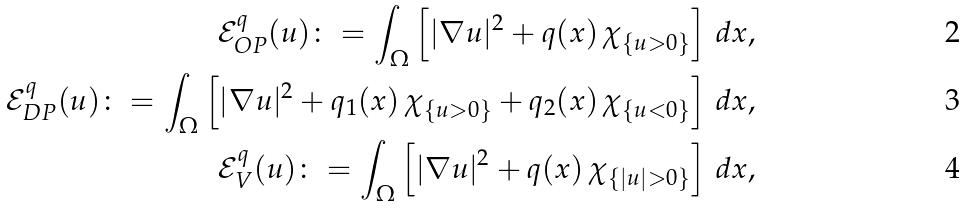Convert formula to latex. <formula><loc_0><loc_0><loc_500><loc_500>\mathcal { E } ^ { q } _ { O P } ( u ) \colon = \int _ { \Omega } \left [ | \nabla u | ^ { 2 } + q ( x ) \, \chi _ { \{ u > 0 \} } \right ] \, d x , \\ \mathcal { E } ^ { q } _ { D P } ( u ) \colon = \int _ { \Omega } \left [ | \nabla u | ^ { 2 } + q _ { 1 } ( x ) \, \chi _ { \{ u > 0 \} } + q _ { 2 } ( x ) \, \chi _ { \{ u < 0 \} } \right ] \, d x , \\ \mathcal { E } ^ { q } _ { V } ( u ) \colon = \int _ { \Omega } \left [ | \nabla u | ^ { 2 } + q ( x ) \, \chi _ { \{ | u | > 0 \} } \right ] \, d x ,</formula> 